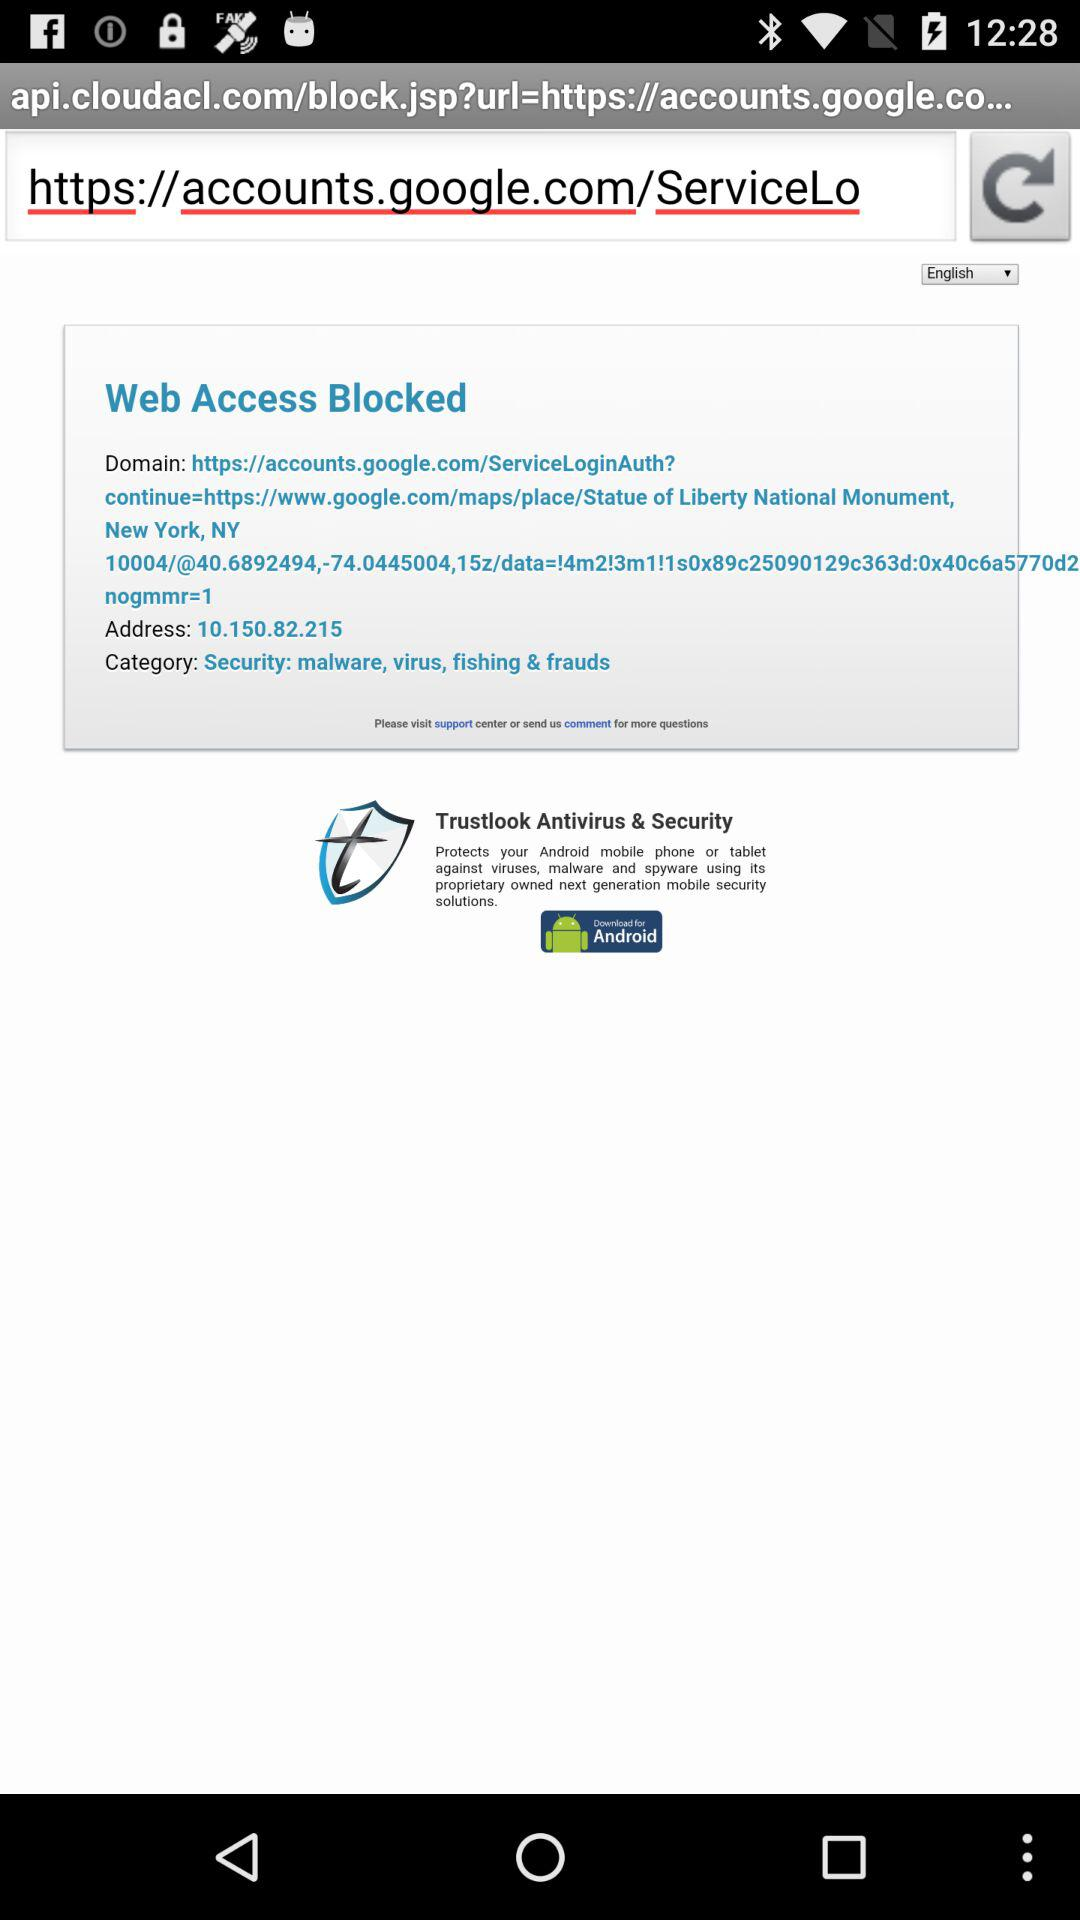What is the category? The category is "Security: malware, virus, fishing & frauds". 